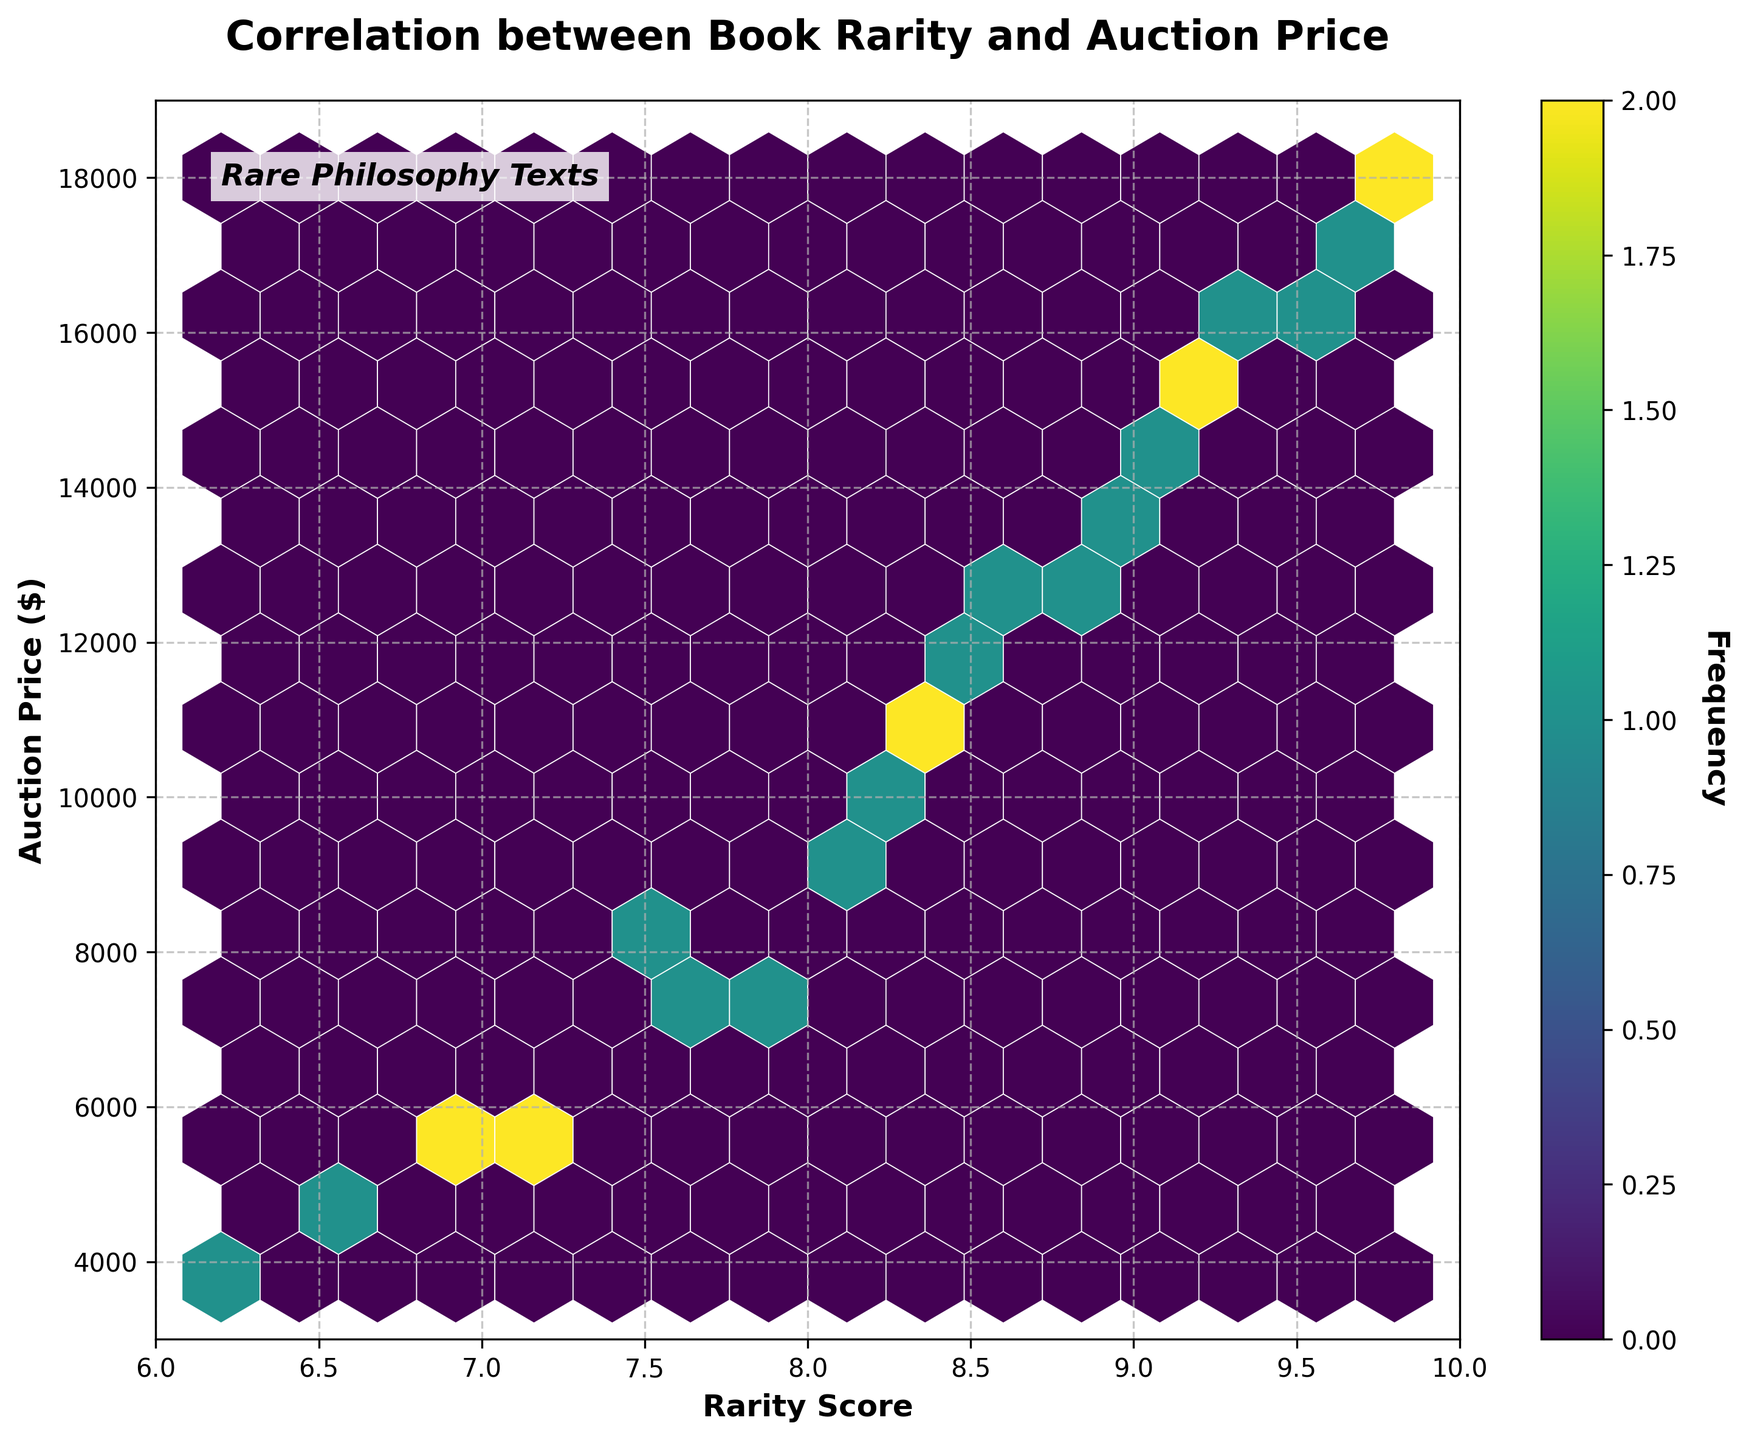What is the title of the hexbin plot? The title of the plot is typically displayed at the top of the figure and identifies the purpose or subject of the plot.
Answer: Correlation between Book Rarity and Auction Price What are the labels of the X and Y axes? The labels of the axes provide the context of what each axis represents, indicating the dimensions or variables being plotted.
Answer: Rarity Score (X), Auction Price ($) (Y) What is the range of the auction prices displayed on the Y-axis? The range of the auction prices can be determined by looking at the minimum and maximum tick marks on the Y-axis.
Answer: 3000 to 19000 What is the range of the rarity scores displayed on the X-axis? The range of the rarity scores can be determined by looking at the minimum and maximum tick marks on the X-axis.
Answer: 6 to 10 How does the frequency distribution appear in the hexbin plot? The frequency distribution in a hexbin plot is often indicated by the color intensity of hexagons. Darker hexagons indicate higher data frequency.
Answer: Higher frequencies are indicated by darker hexagons Which rarity score roughly correlates with the highest auction prices? To determine correlation, observe the clustering of high auction prices on the Y-axis with the corresponding rarity scores on the X-axis.
Answer: 9.8 Do higher rarity scores typically correlate with higher auction prices? By examining the overall trend in the scatter of hexagons, one can infer if there's a general upward trend in the auction prices with increasing rarity scores.
Answer: Yes What is the most common auction price range for the given rarity scores? Identify the color intensity or the density of hexagons clustered around certain auction prices to determine the most frequent range.
Answer: 10000 to 12000 Between which rarity scores do the densest clusters of data points appear? The densest clusters can be found by looking for the area with the highest concentration of dark-colored hexagons.
Answer: 8 to 9 Is there any visualization element indicating the frequency of data points? If yes, what is it? Hexbin plots use color intensity or a color bar to indicate frequencies. Look for any coloring element or legend associated with frequency.
Answer: Yes, a color bar 